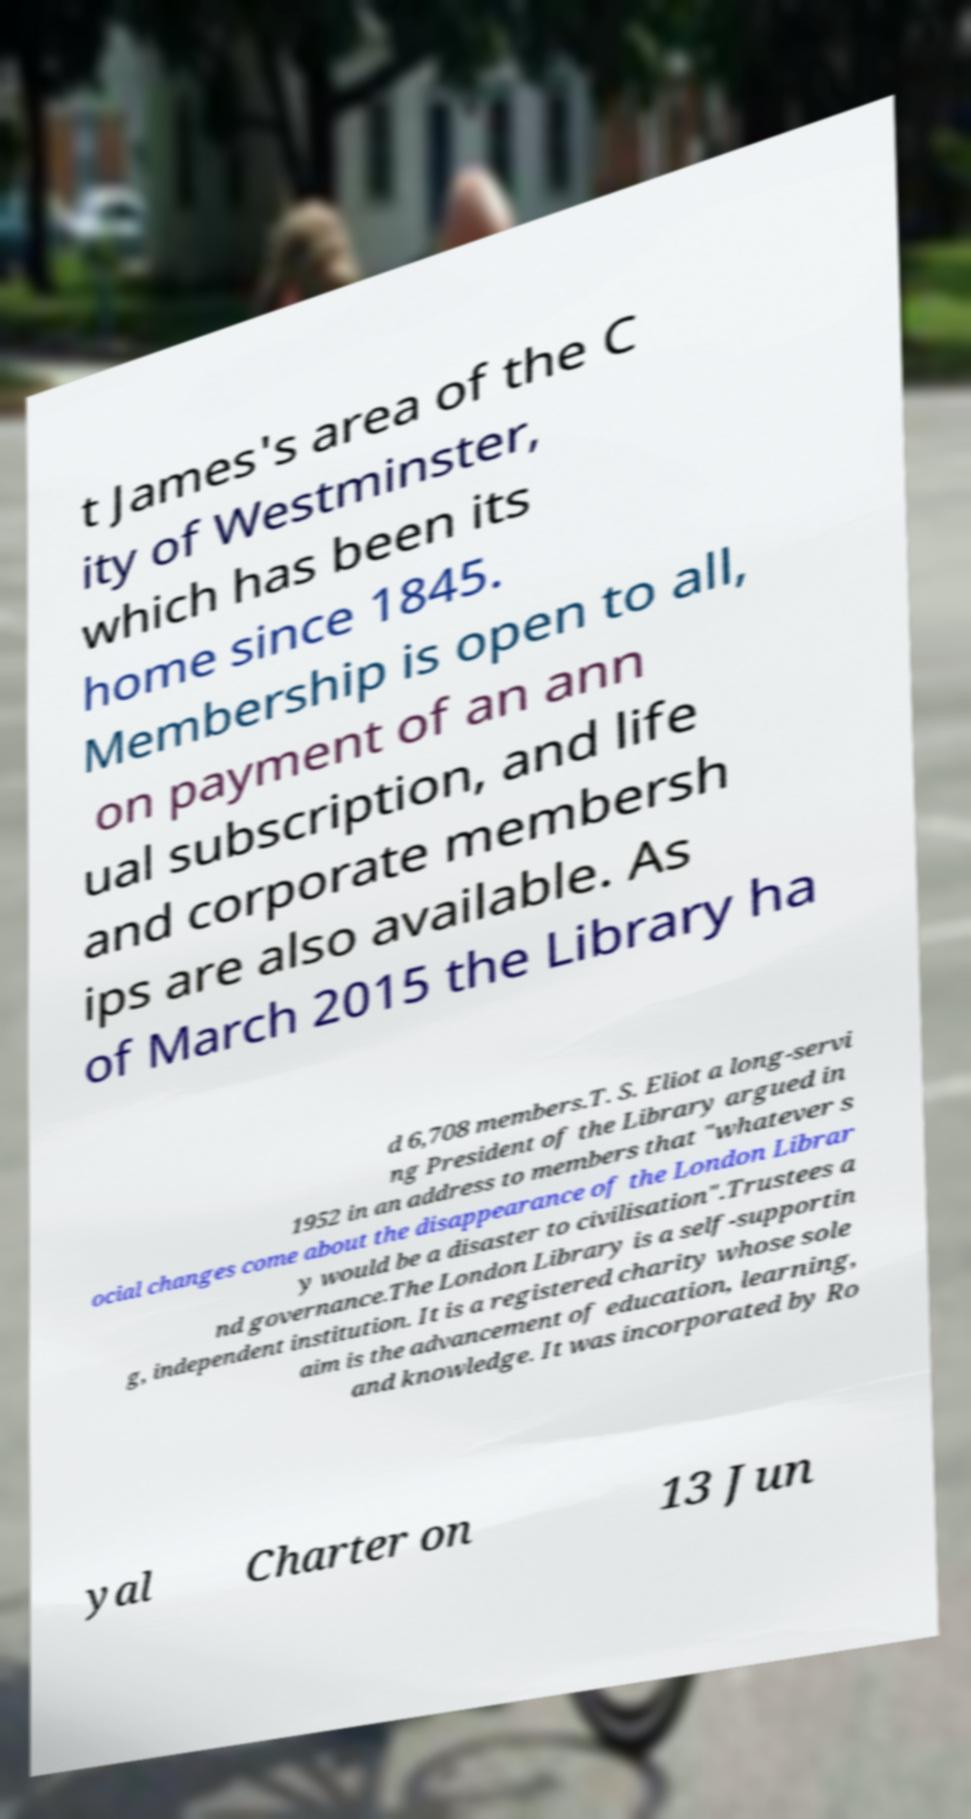Can you read and provide the text displayed in the image?This photo seems to have some interesting text. Can you extract and type it out for me? t James's area of the C ity of Westminster, which has been its home since 1845. Membership is open to all, on payment of an ann ual subscription, and life and corporate membersh ips are also available. As of March 2015 the Library ha d 6,708 members.T. S. Eliot a long-servi ng President of the Library argued in 1952 in an address to members that "whatever s ocial changes come about the disappearance of the London Librar y would be a disaster to civilisation".Trustees a nd governance.The London Library is a self-supportin g, independent institution. It is a registered charity whose sole aim is the advancement of education, learning, and knowledge. It was incorporated by Ro yal Charter on 13 Jun 